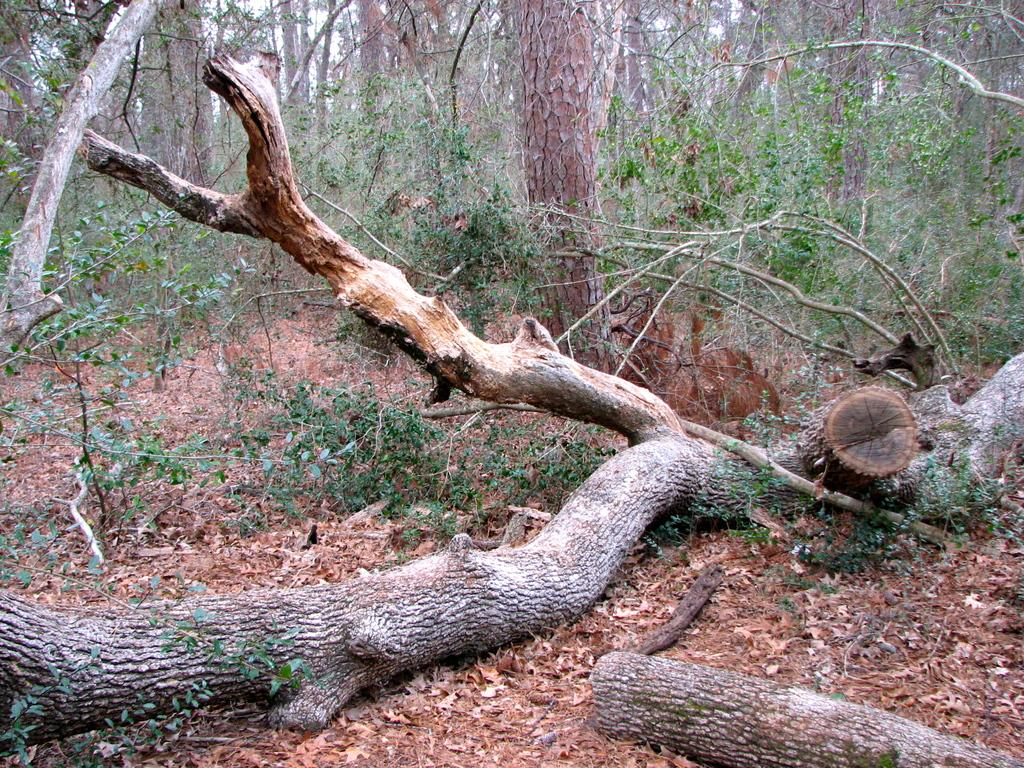What can be seen in the foreground of the image? There are trunks of trees in the foreground of the image. What type of vegetation is visible in the image? Leaves and plants are visible in the image. What is visible in the background of the image? There are multiple trees in the background of the image. What type of fuel can be seen powering the trees in the image? There is no fuel present in the image, as trees do not require fuel to grow or function. What kind of veil is draped over the leaves in the image? There is no veil present in the image; the leaves are visible without any covering. 